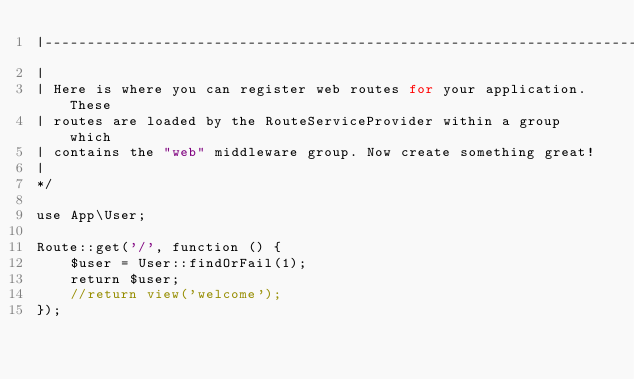Convert code to text. <code><loc_0><loc_0><loc_500><loc_500><_PHP_>|--------------------------------------------------------------------------
|
| Here is where you can register web routes for your application. These
| routes are loaded by the RouteServiceProvider within a group which
| contains the "web" middleware group. Now create something great!
|
*/

use App\User;

Route::get('/', function () {
	$user = User::findOrFail(1);
	return $user;
    //return view('welcome');
});
</code> 